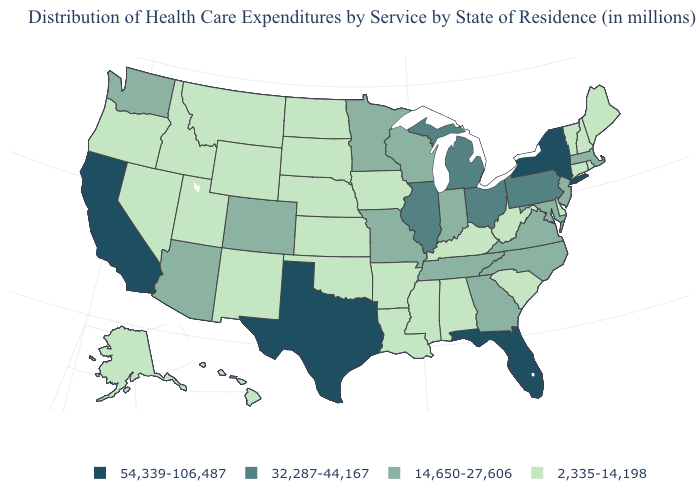What is the value of South Carolina?
Write a very short answer. 2,335-14,198. What is the value of Iowa?
Write a very short answer. 2,335-14,198. Is the legend a continuous bar?
Answer briefly. No. Which states have the highest value in the USA?
Concise answer only. California, Florida, New York, Texas. What is the lowest value in the USA?
Be succinct. 2,335-14,198. Among the states that border Kansas , does Nebraska have the highest value?
Keep it brief. No. Which states have the highest value in the USA?
Quick response, please. California, Florida, New York, Texas. What is the highest value in the Northeast ?
Give a very brief answer. 54,339-106,487. Among the states that border Colorado , does Wyoming have the lowest value?
Write a very short answer. Yes. Does Minnesota have a higher value than North Carolina?
Answer briefly. No. Name the states that have a value in the range 32,287-44,167?
Short answer required. Illinois, Michigan, Ohio, Pennsylvania. Among the states that border Delaware , does New Jersey have the highest value?
Short answer required. No. Name the states that have a value in the range 32,287-44,167?
Write a very short answer. Illinois, Michigan, Ohio, Pennsylvania. What is the value of Georgia?
Write a very short answer. 14,650-27,606. Name the states that have a value in the range 2,335-14,198?
Concise answer only. Alabama, Alaska, Arkansas, Connecticut, Delaware, Hawaii, Idaho, Iowa, Kansas, Kentucky, Louisiana, Maine, Mississippi, Montana, Nebraska, Nevada, New Hampshire, New Mexico, North Dakota, Oklahoma, Oregon, Rhode Island, South Carolina, South Dakota, Utah, Vermont, West Virginia, Wyoming. 